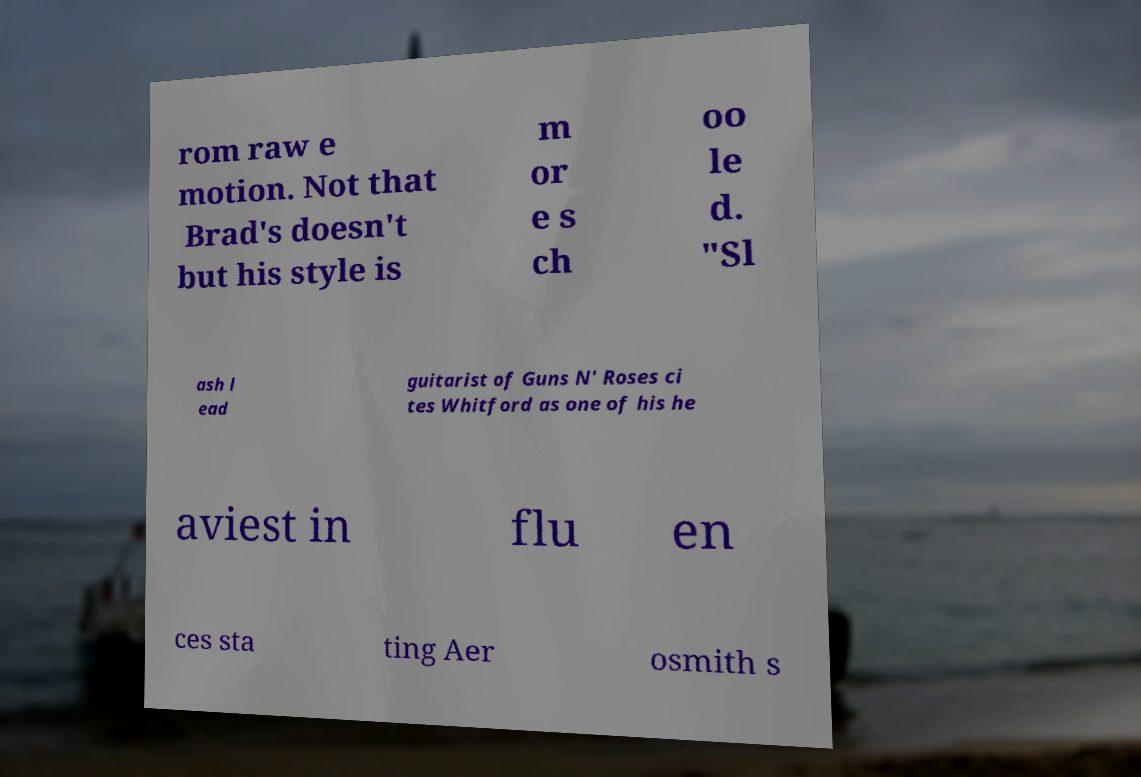Please identify and transcribe the text found in this image. rom raw e motion. Not that Brad's doesn't but his style is m or e s ch oo le d. "Sl ash l ead guitarist of Guns N' Roses ci tes Whitford as one of his he aviest in flu en ces sta ting Aer osmith s 